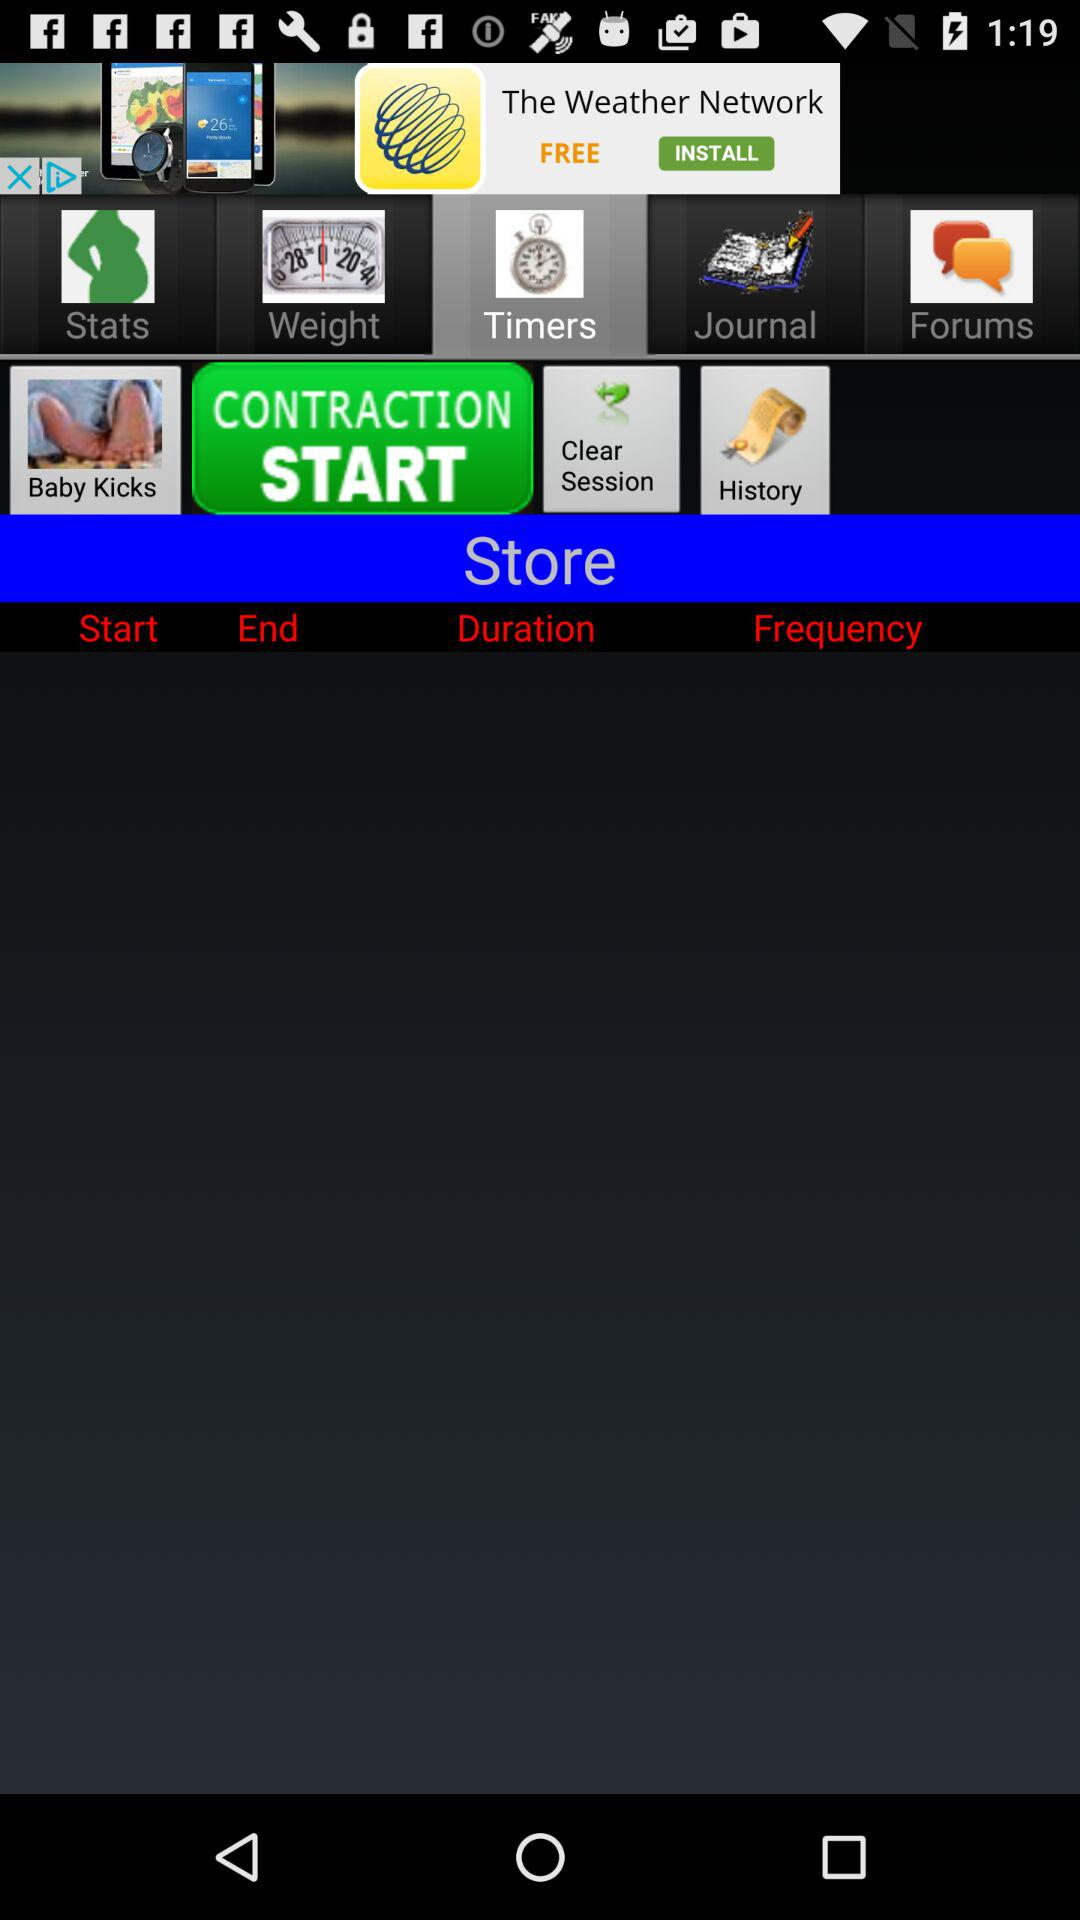What's the selected category? The selected category is "Timers". 